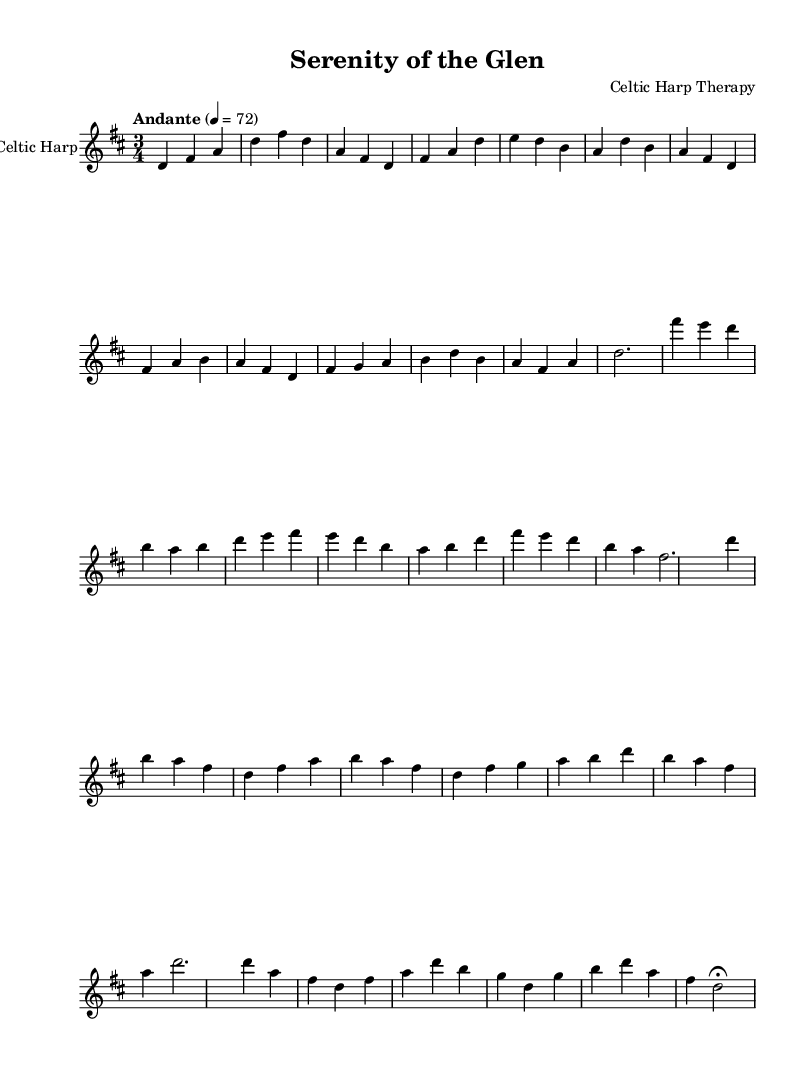What is the key signature of this music? The key signature is determined by the sharps or flats indicated at the beginning of the staff. In this piece, there are two sharps (F# and C#) displayed, which corresponds to the key of D major.
Answer: D major What is the time signature of this music? The time signature is shown at the beginning of the score, specifically right after the key signature. It indicates that there are three beats in each measure, represented by "3/4".
Answer: 3/4 What is the tempo marking for this piece? The tempo marking is found below the time signature and provides the speed of the music. In this case, it indicates "Andante", with a tempo of 72 beats per minute, which denotes a moderate pace.
Answer: Andante How many sections are in the music? To determine the number of sections, we analyze the structure of the music outlined in the score. It includes an intro, A section, B section, A' (shortened A), and an outro. This totals five distinct sections.
Answer: 5 What dynamics are indicated in the A section? The dynamics are represented by symbols or terms that communicate the volume level of the music. In this case, there are no specific dynamics written, suggesting a consistent volume throughout the A section.
Answer: None What is the final note of the piece? The final note can be identified by observing the last measure of the outro section, where it culminates with the note "D", which is held as indicated by the fermata.
Answer: D 